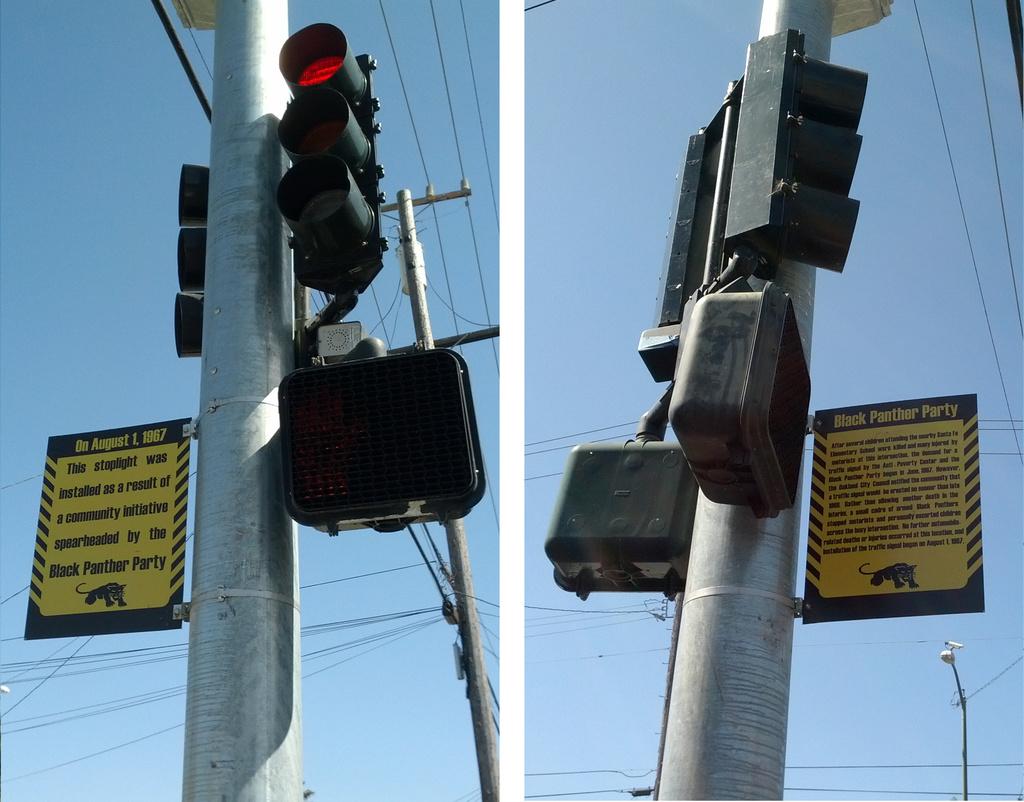What is the date written on the top of the signs?
Your response must be concise. August 1, 1967. 